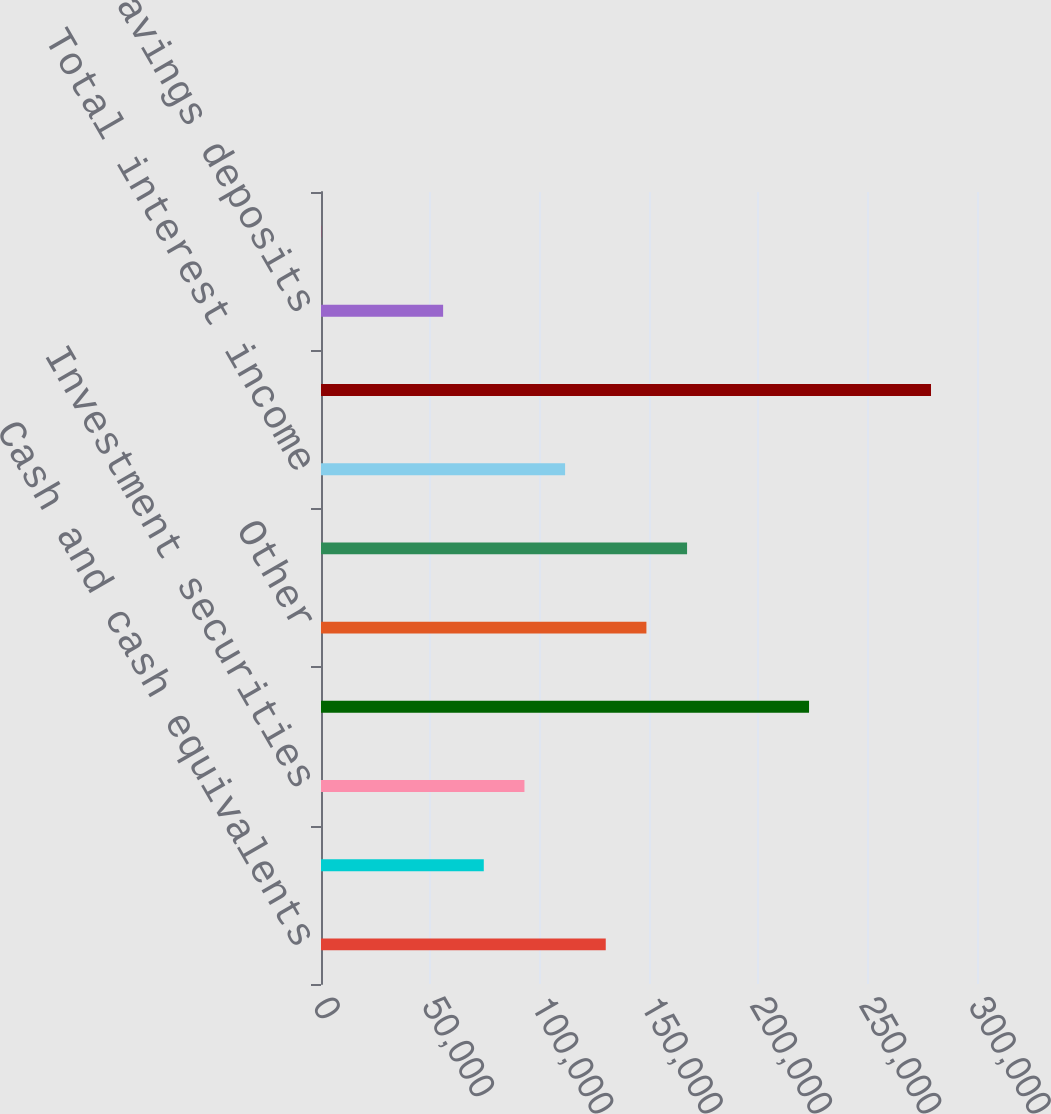Convert chart to OTSL. <chart><loc_0><loc_0><loc_500><loc_500><bar_chart><fcel>Cash and cash equivalents<fcel>Restricted cash<fcel>Investment securities<fcel>Credit card<fcel>Other<fcel>Total loan receivables<fcel>Total interest income<fcel>Time deposits<fcel>Savings deposits<fcel>Other interest-bearing<nl><fcel>130223<fcel>74443.4<fcel>93036.5<fcel>223188<fcel>148816<fcel>167409<fcel>111630<fcel>278968<fcel>55850.3<fcel>71<nl></chart> 